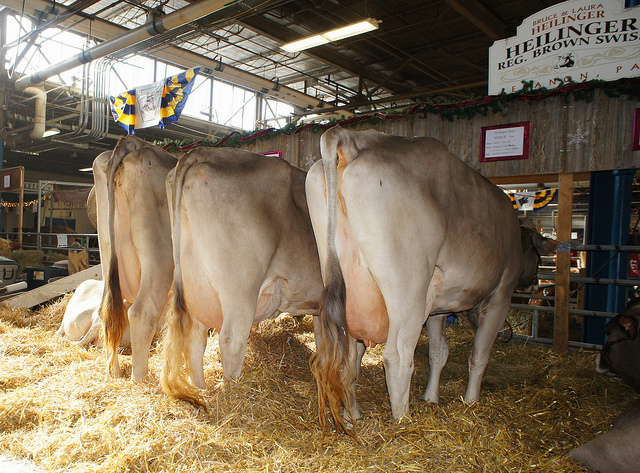Identify and read out the text in this image. HEILING GER R BROWN S P A HEILINGER LAURA 